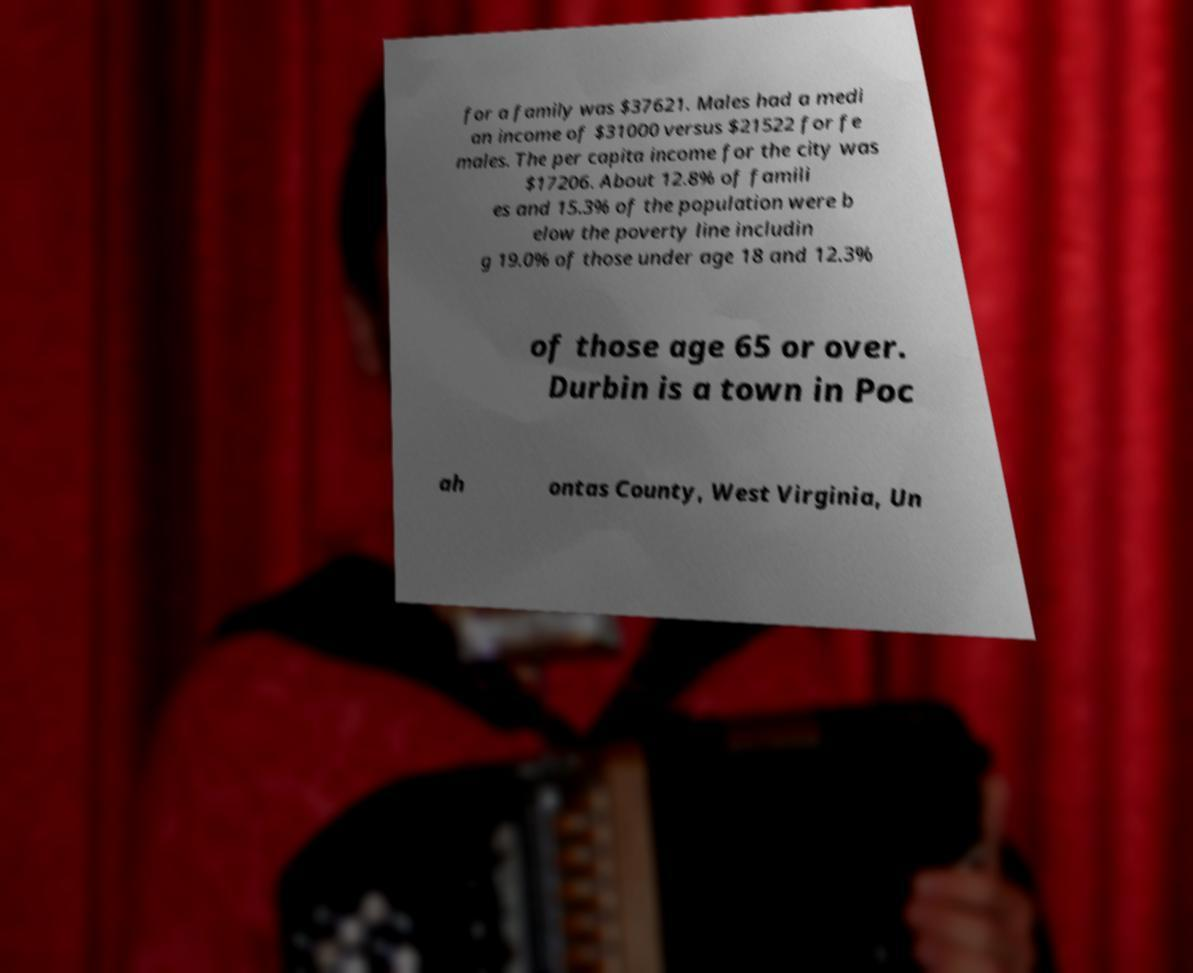There's text embedded in this image that I need extracted. Can you transcribe it verbatim? for a family was $37621. Males had a medi an income of $31000 versus $21522 for fe males. The per capita income for the city was $17206. About 12.8% of famili es and 15.3% of the population were b elow the poverty line includin g 19.0% of those under age 18 and 12.3% of those age 65 or over. Durbin is a town in Poc ah ontas County, West Virginia, Un 